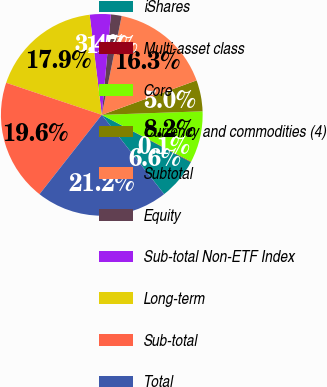Convert chart. <chart><loc_0><loc_0><loc_500><loc_500><pie_chart><fcel>iShares<fcel>Multi-asset class<fcel>Core<fcel>Currency and commodities (4)<fcel>Subtotal<fcel>Equity<fcel>Sub-total Non-ETF Index<fcel>Long-term<fcel>Sub-total<fcel>Total<nl><fcel>6.62%<fcel>0.09%<fcel>8.25%<fcel>4.99%<fcel>16.29%<fcel>1.72%<fcel>3.36%<fcel>17.93%<fcel>19.56%<fcel>21.19%<nl></chart> 